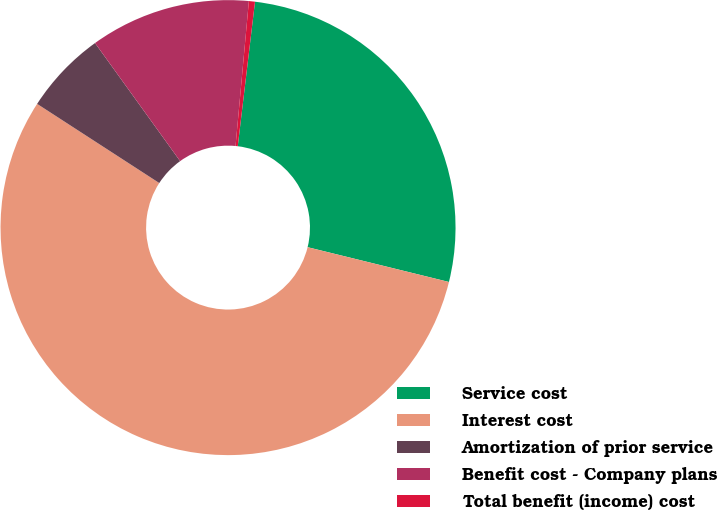<chart> <loc_0><loc_0><loc_500><loc_500><pie_chart><fcel>Service cost<fcel>Interest cost<fcel>Amortization of prior service<fcel>Benefit cost - Company plans<fcel>Total benefit (income) cost<nl><fcel>26.95%<fcel>55.31%<fcel>5.91%<fcel>11.4%<fcel>0.43%<nl></chart> 